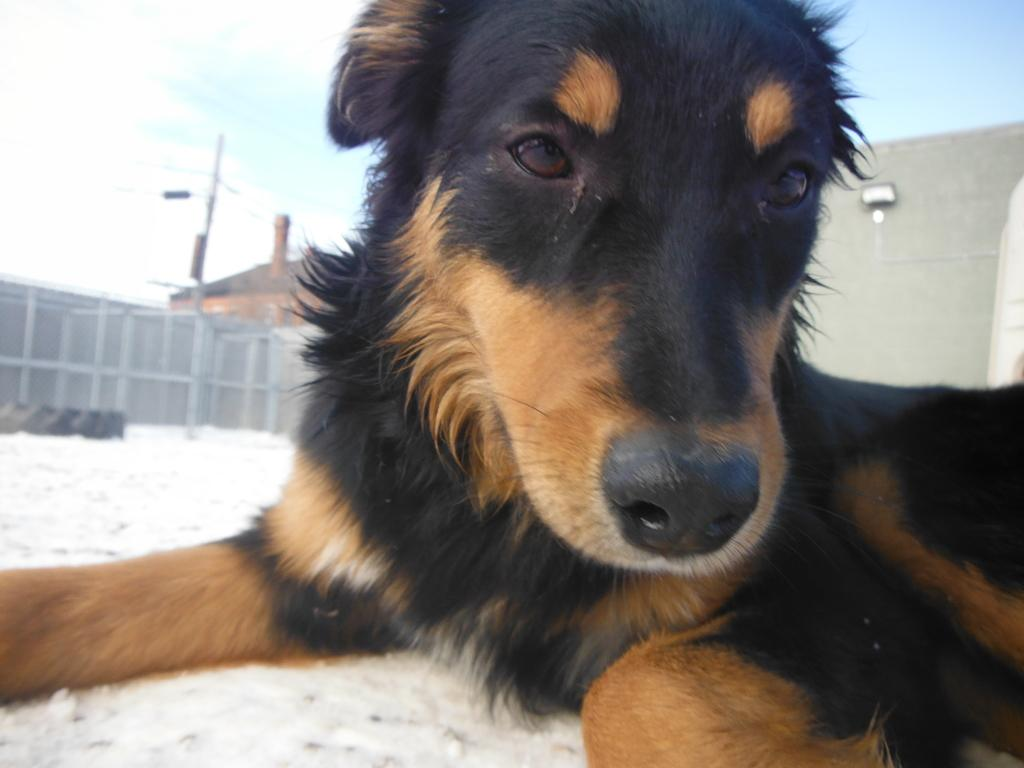What type of animal is present in the image? There is a dog in the image. What is the dog standing or sitting on? The dog is on a surface in the image. What can be seen in the background of the image? There is a wall, a house, and the sky visible in the background of the image. How many cars are parked next to the scarecrow in the image? There are no cars or scarecrows present in the image; it features a dog on a surface with a wall, house, and sky in the background. 